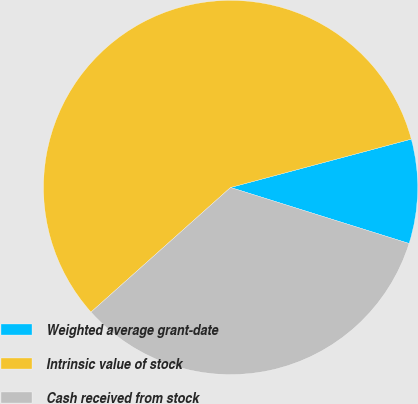<chart> <loc_0><loc_0><loc_500><loc_500><pie_chart><fcel>Weighted average grant-date<fcel>Intrinsic value of stock<fcel>Cash received from stock<nl><fcel>9.0%<fcel>57.44%<fcel>33.56%<nl></chart> 